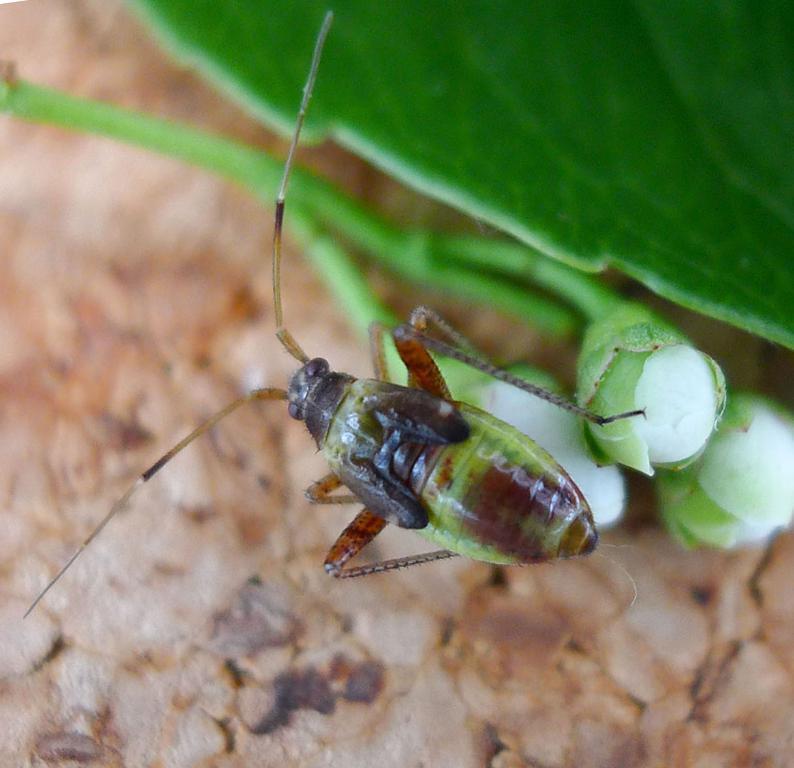How would you summarize this image in a sentence or two? In this picture we can see an insect on the bud and behind the insect there is a leaf, buds and an object. 